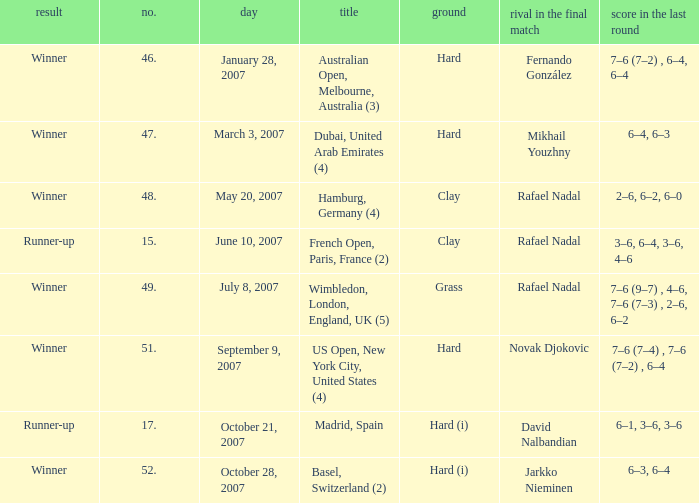Who are the two players participating in a final match with scores 3-6, 6-4, 3-6, and 4-6? Rafael Nadal. Help me parse the entirety of this table. {'header': ['result', 'no.', 'day', 'title', 'ground', 'rival in the final match', 'score in the last round'], 'rows': [['Winner', '46.', 'January 28, 2007', 'Australian Open, Melbourne, Australia (3)', 'Hard', 'Fernando González', '7–6 (7–2) , 6–4, 6–4'], ['Winner', '47.', 'March 3, 2007', 'Dubai, United Arab Emirates (4)', 'Hard', 'Mikhail Youzhny', '6–4, 6–3'], ['Winner', '48.', 'May 20, 2007', 'Hamburg, Germany (4)', 'Clay', 'Rafael Nadal', '2–6, 6–2, 6–0'], ['Runner-up', '15.', 'June 10, 2007', 'French Open, Paris, France (2)', 'Clay', 'Rafael Nadal', '3–6, 6–4, 3–6, 4–6'], ['Winner', '49.', 'July 8, 2007', 'Wimbledon, London, England, UK (5)', 'Grass', 'Rafael Nadal', '7–6 (9–7) , 4–6, 7–6 (7–3) , 2–6, 6–2'], ['Winner', '51.', 'September 9, 2007', 'US Open, New York City, United States (4)', 'Hard', 'Novak Djokovic', '7–6 (7–4) , 7–6 (7–2) , 6–4'], ['Runner-up', '17.', 'October 21, 2007', 'Madrid, Spain', 'Hard (i)', 'David Nalbandian', '6–1, 3–6, 3–6'], ['Winner', '52.', 'October 28, 2007', 'Basel, Switzerland (2)', 'Hard (i)', 'Jarkko Nieminen', '6–3, 6–4']]} 